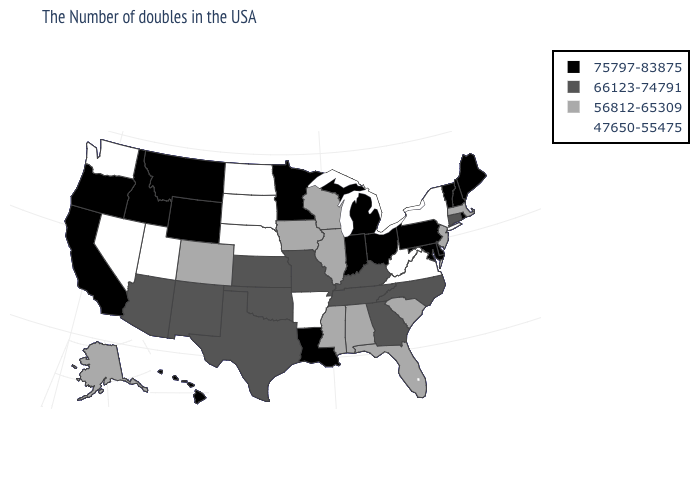Among the states that border Kentucky , which have the lowest value?
Keep it brief. Virginia, West Virginia. What is the value of Wyoming?
Keep it brief. 75797-83875. What is the lowest value in the USA?
Keep it brief. 47650-55475. What is the value of Tennessee?
Answer briefly. 66123-74791. Does Iowa have the same value as South Carolina?
Answer briefly. Yes. Does Georgia have a lower value than Oregon?
Answer briefly. Yes. What is the value of Oklahoma?
Write a very short answer. 66123-74791. Which states hav the highest value in the MidWest?
Quick response, please. Ohio, Michigan, Indiana, Minnesota. Name the states that have a value in the range 56812-65309?
Write a very short answer. Massachusetts, New Jersey, South Carolina, Florida, Alabama, Wisconsin, Illinois, Mississippi, Iowa, Colorado, Alaska. Does the first symbol in the legend represent the smallest category?
Concise answer only. No. Name the states that have a value in the range 66123-74791?
Write a very short answer. Connecticut, North Carolina, Georgia, Kentucky, Tennessee, Missouri, Kansas, Oklahoma, Texas, New Mexico, Arizona. Among the states that border Colorado , which have the lowest value?
Answer briefly. Nebraska, Utah. What is the lowest value in the South?
Quick response, please. 47650-55475. How many symbols are there in the legend?
Concise answer only. 4. 